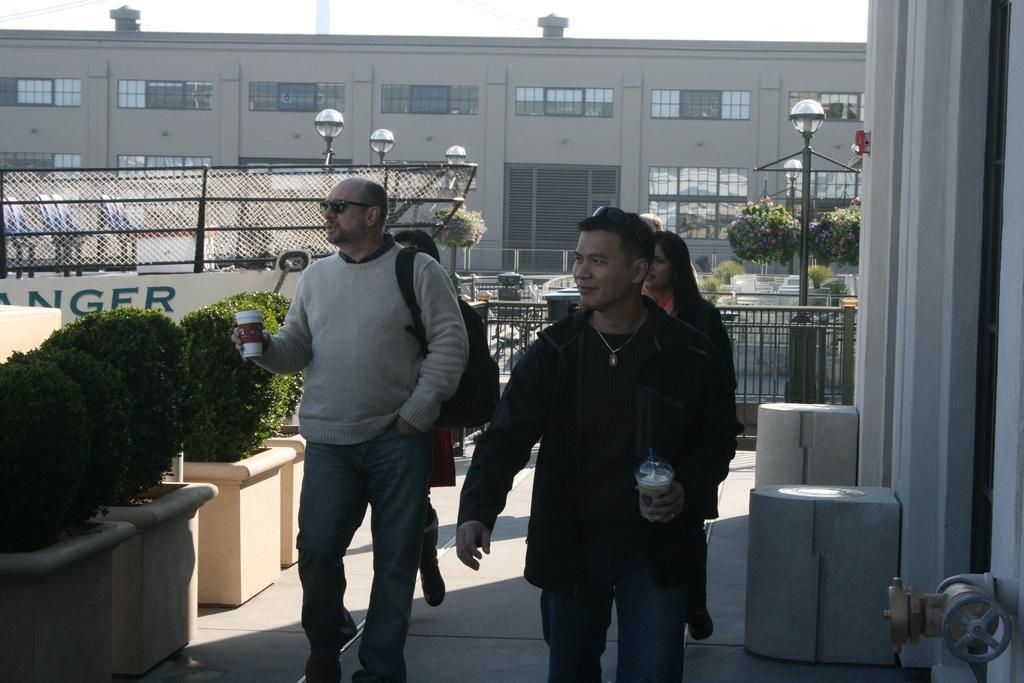Can you describe this image briefly? In the center of the image we can see some persons are walking, some of them are holding glass and carrying bag. In the background of the image we can see building, door, windows, mesh, electric light poles, plants, barricades and some vehicles. At the bottom of the image we can see pots, plants, wall, some objects, floor. At the top of the image we can see the sky. 